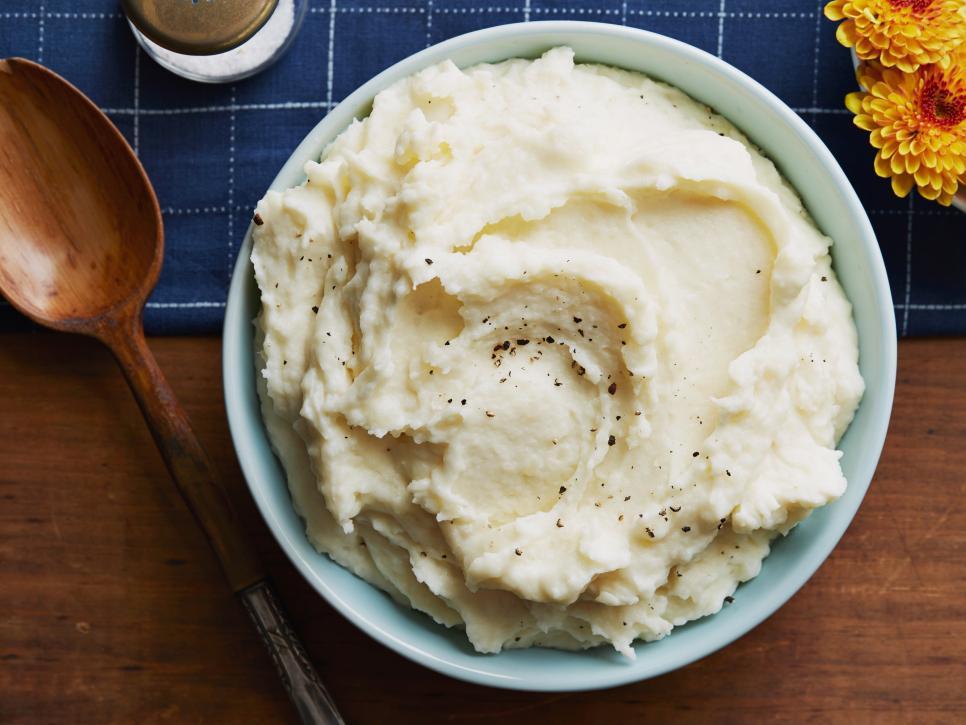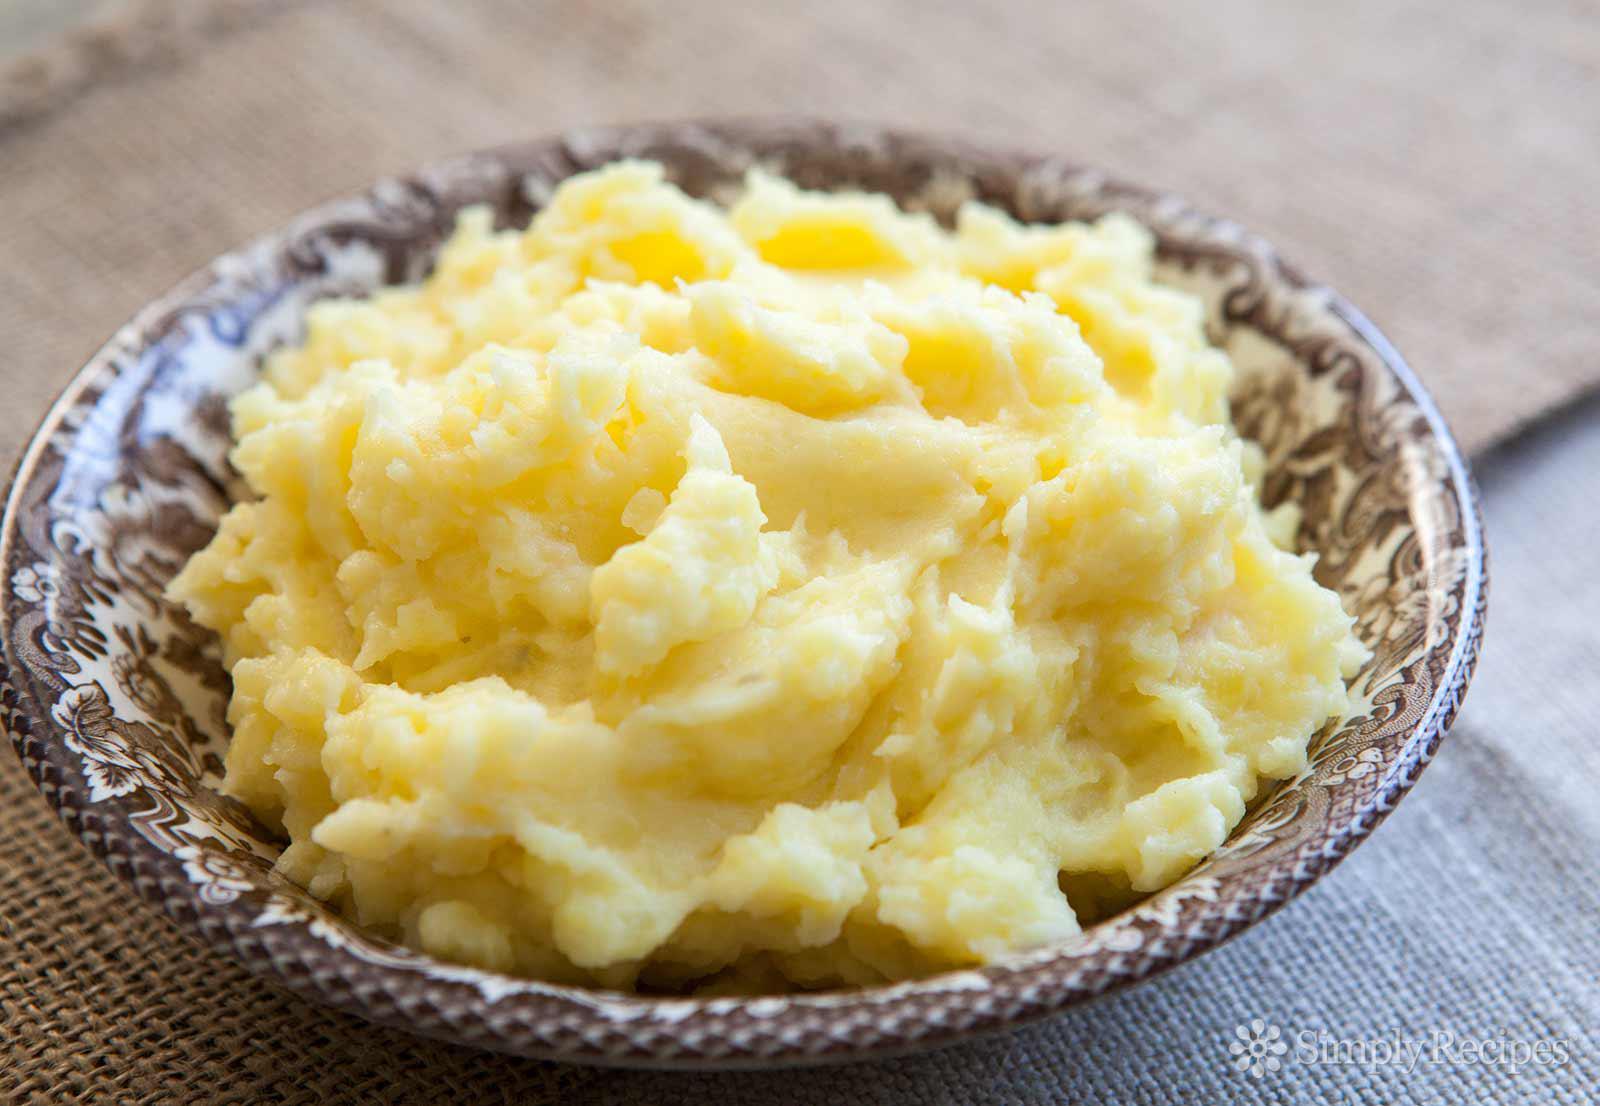The first image is the image on the left, the second image is the image on the right. Considering the images on both sides, is "One image shows a bowl of mashed potatoes with no spoon near it." valid? Answer yes or no. Yes. 